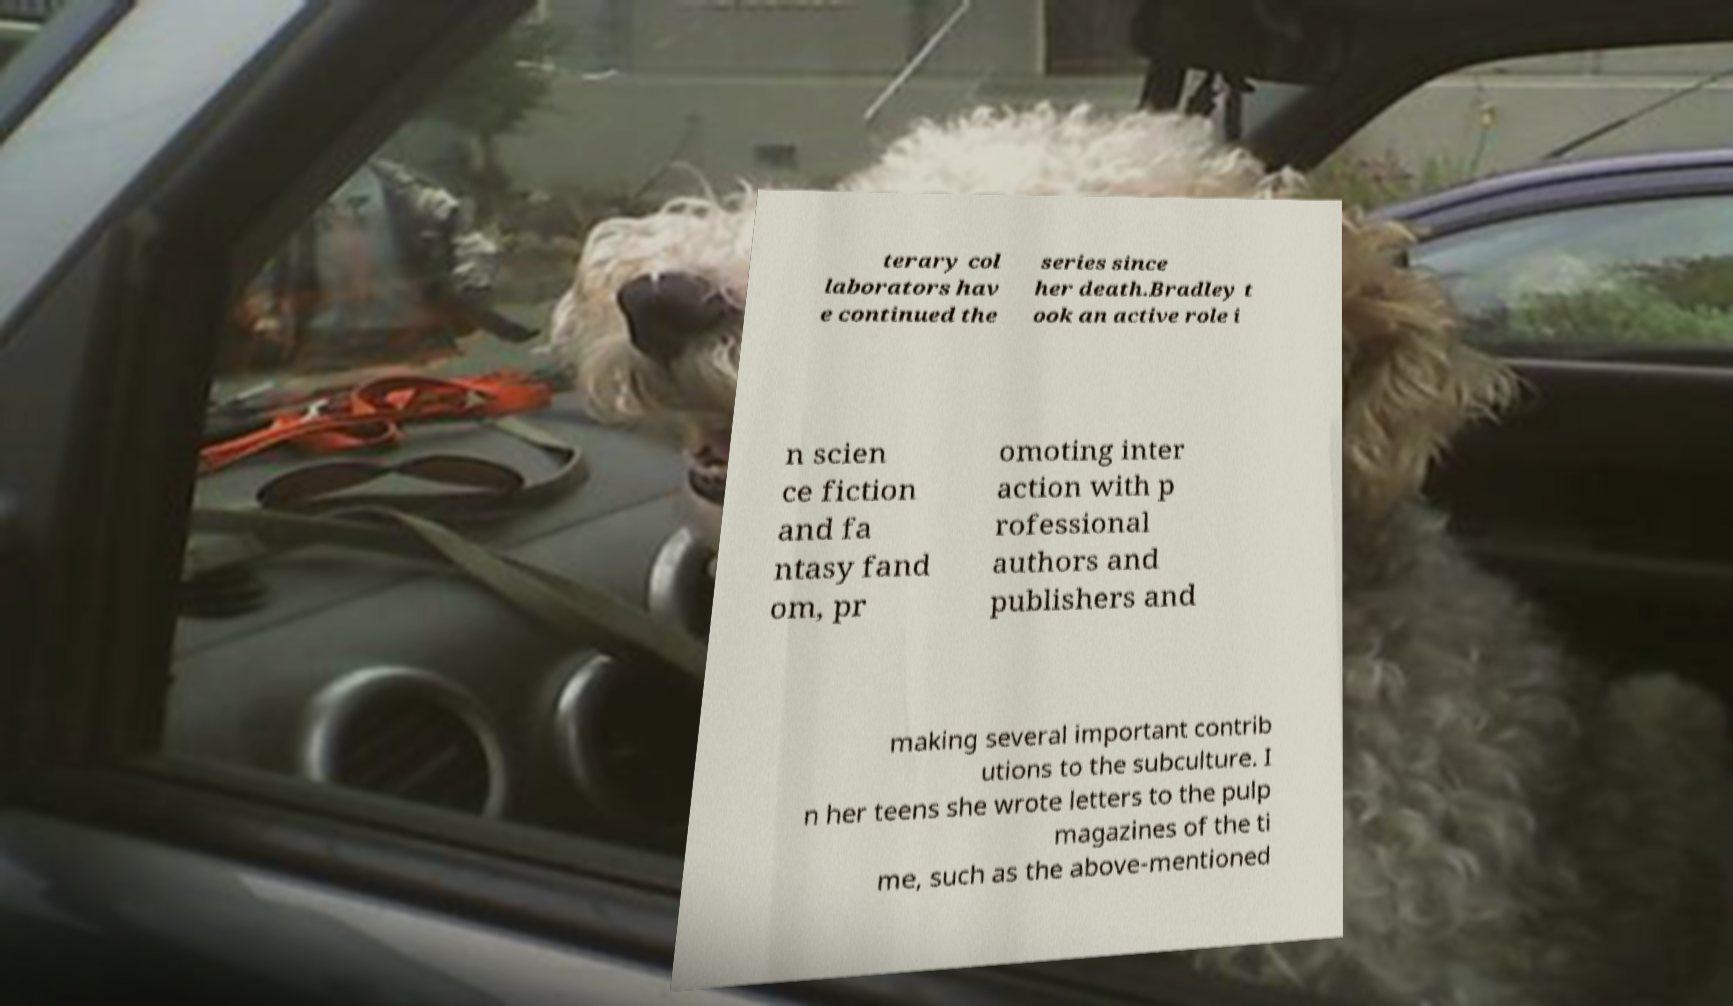Can you accurately transcribe the text from the provided image for me? terary col laborators hav e continued the series since her death.Bradley t ook an active role i n scien ce fiction and fa ntasy fand om, pr omoting inter action with p rofessional authors and publishers and making several important contrib utions to the subculture. I n her teens she wrote letters to the pulp magazines of the ti me, such as the above-mentioned 